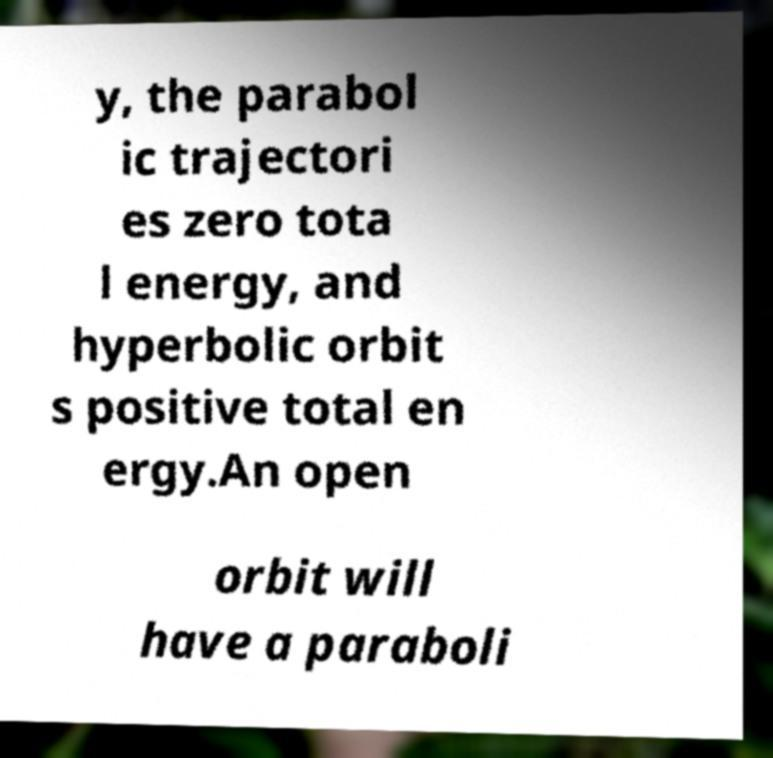There's text embedded in this image that I need extracted. Can you transcribe it verbatim? y, the parabol ic trajectori es zero tota l energy, and hyperbolic orbit s positive total en ergy.An open orbit will have a paraboli 